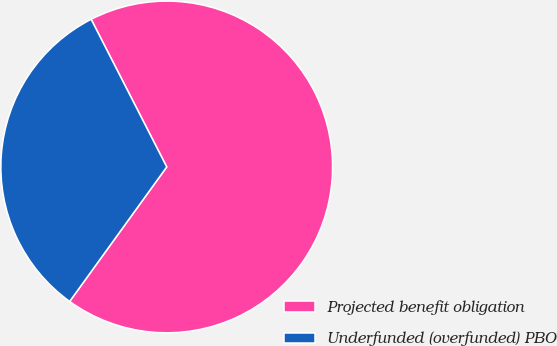Convert chart to OTSL. <chart><loc_0><loc_0><loc_500><loc_500><pie_chart><fcel>Projected benefit obligation<fcel>Underfunded (overfunded) PBO<nl><fcel>67.48%<fcel>32.52%<nl></chart> 